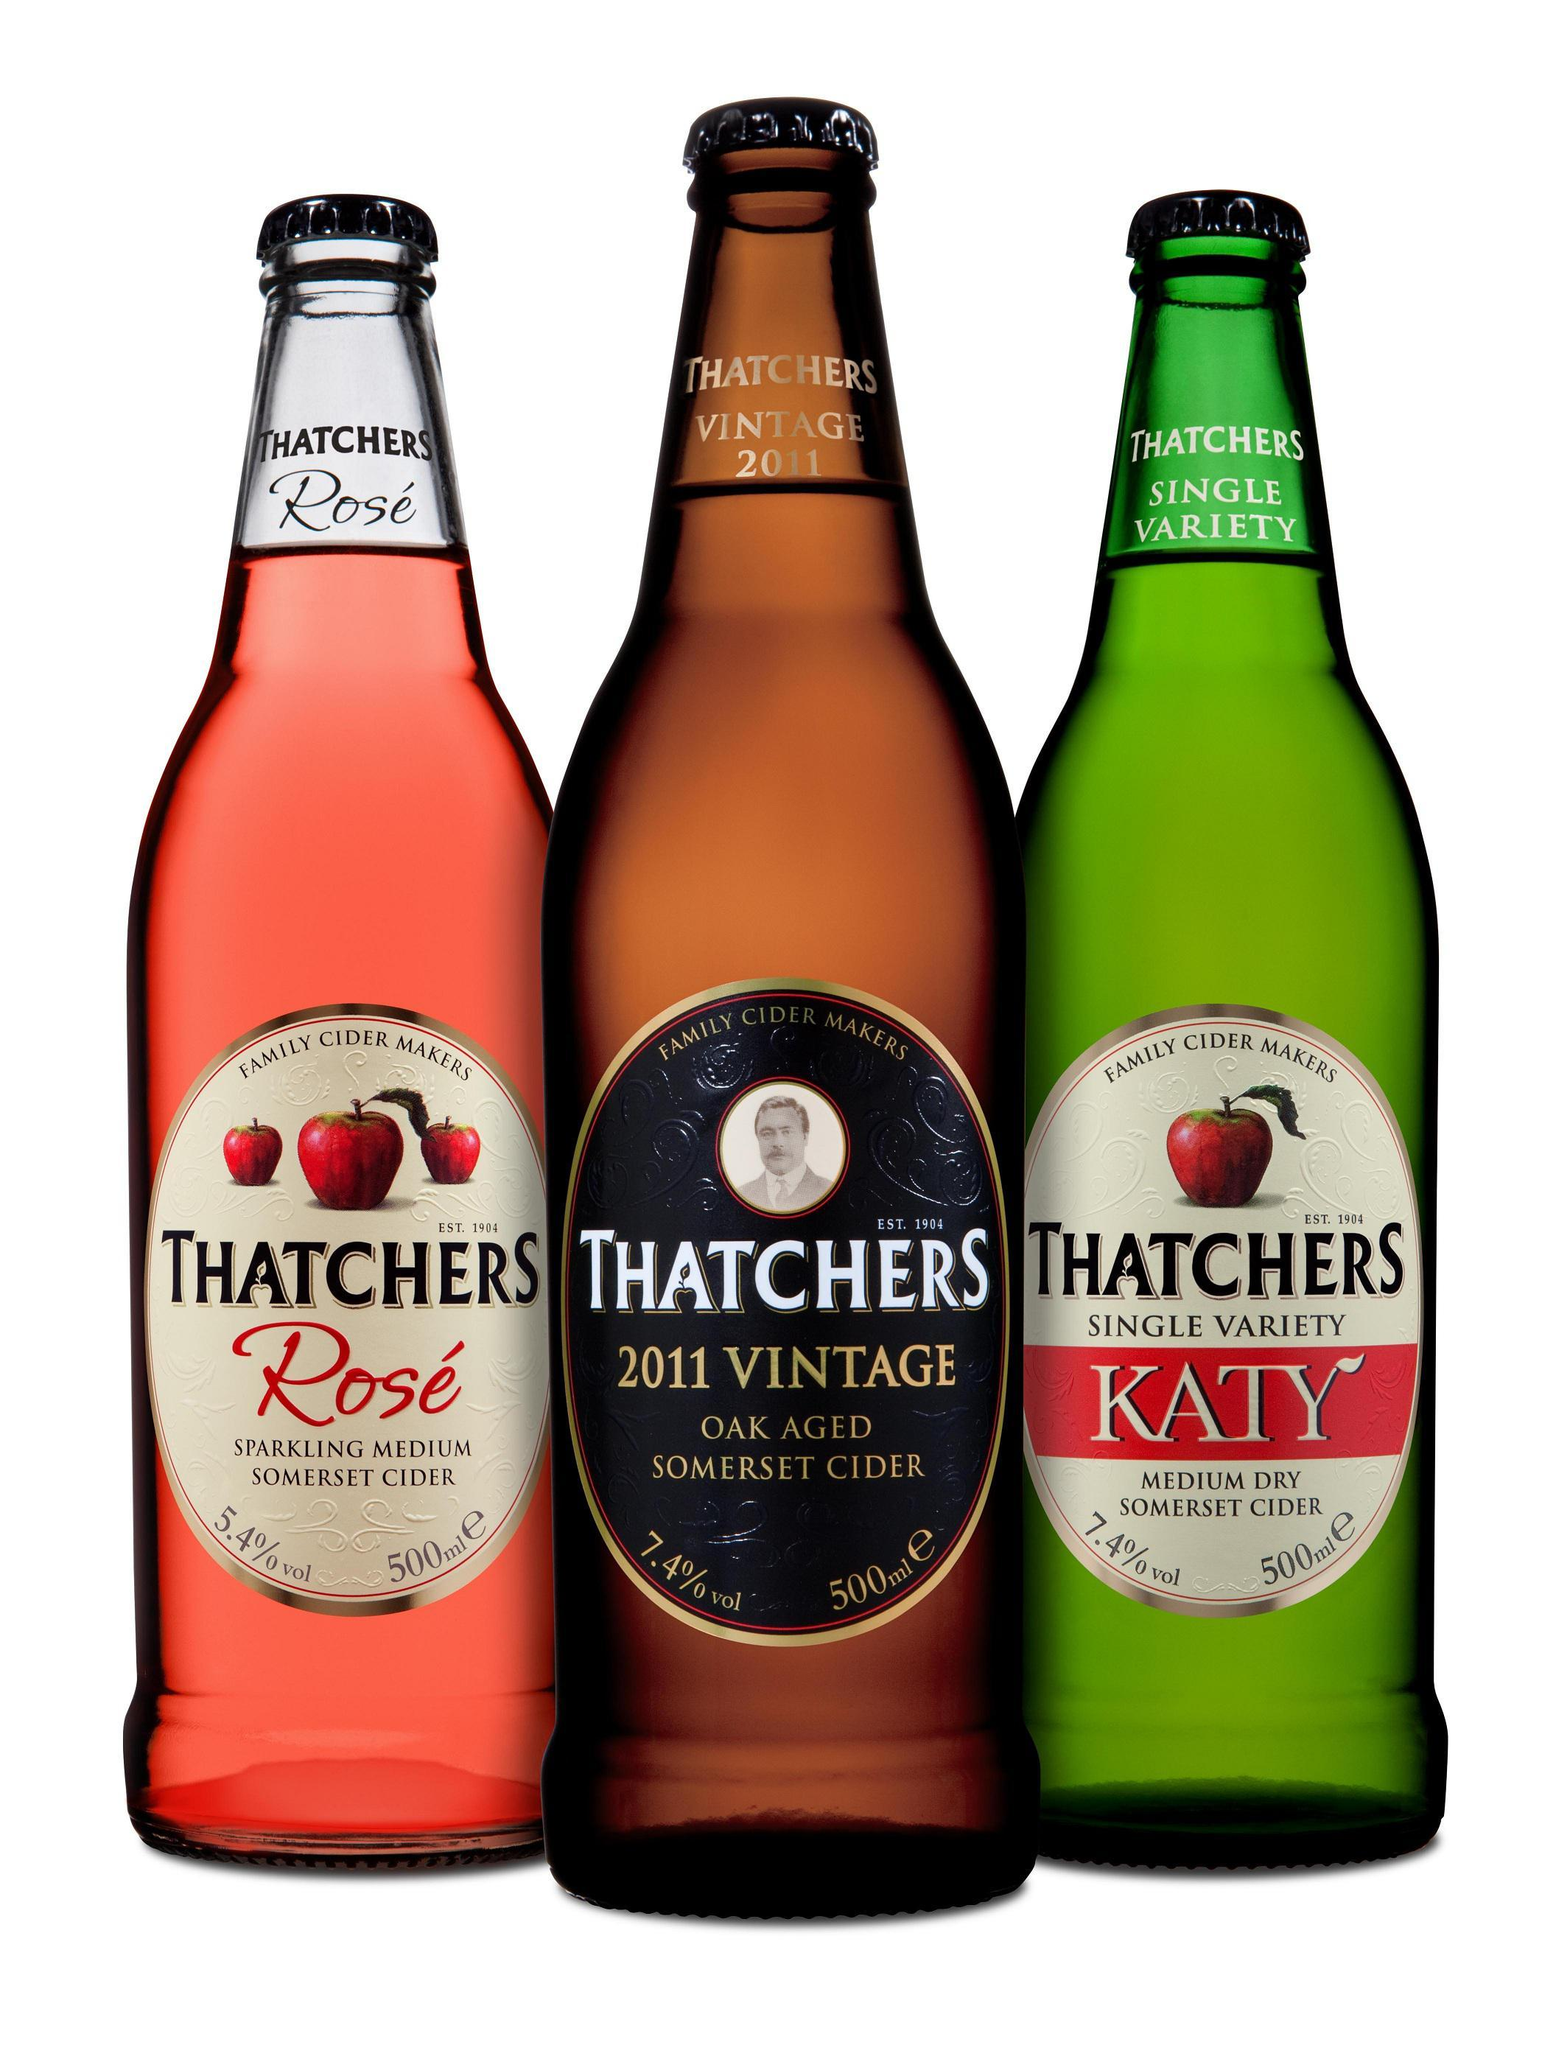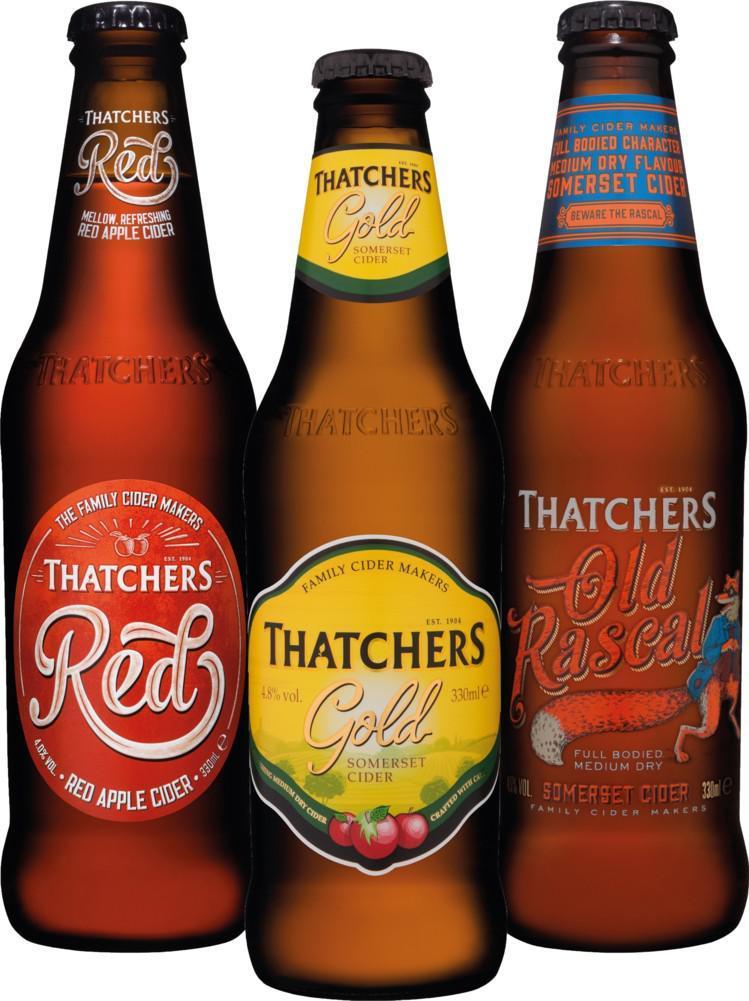The first image is the image on the left, the second image is the image on the right. Examine the images to the left and right. Is the description "Each image contains the same number of capped bottles, all with different labels." accurate? Answer yes or no. Yes. The first image is the image on the left, the second image is the image on the right. Assess this claim about the two images: "The right and left images contain the same number of bottles.". Correct or not? Answer yes or no. Yes. 